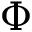<formula> <loc_0><loc_0><loc_500><loc_500>\Phi</formula> 